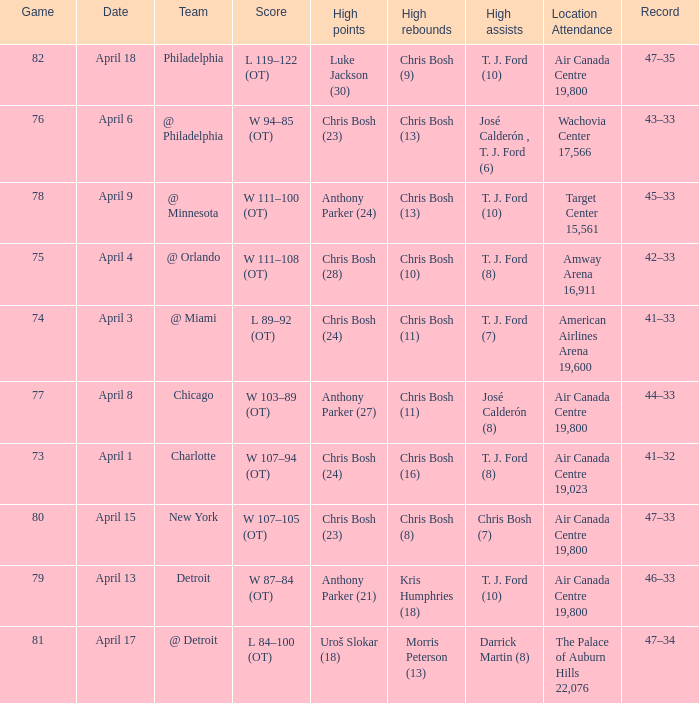What were the assists on April 8 in game less than 78? José Calderón (8). 